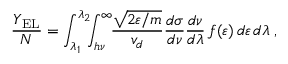<formula> <loc_0><loc_0><loc_500><loc_500>\frac { Y _ { E L } } { N } = \int _ { \lambda _ { 1 } } ^ { \lambda _ { 2 } } \, \int _ { h \nu } ^ { \infty } \, \frac { \sqrt { 2 \varepsilon / m } } { v _ { d } } \frac { d \sigma } { d \nu } \frac { d \nu } { d \lambda } \, f ( \varepsilon ) \, d \varepsilon \, d \lambda \, ,</formula> 